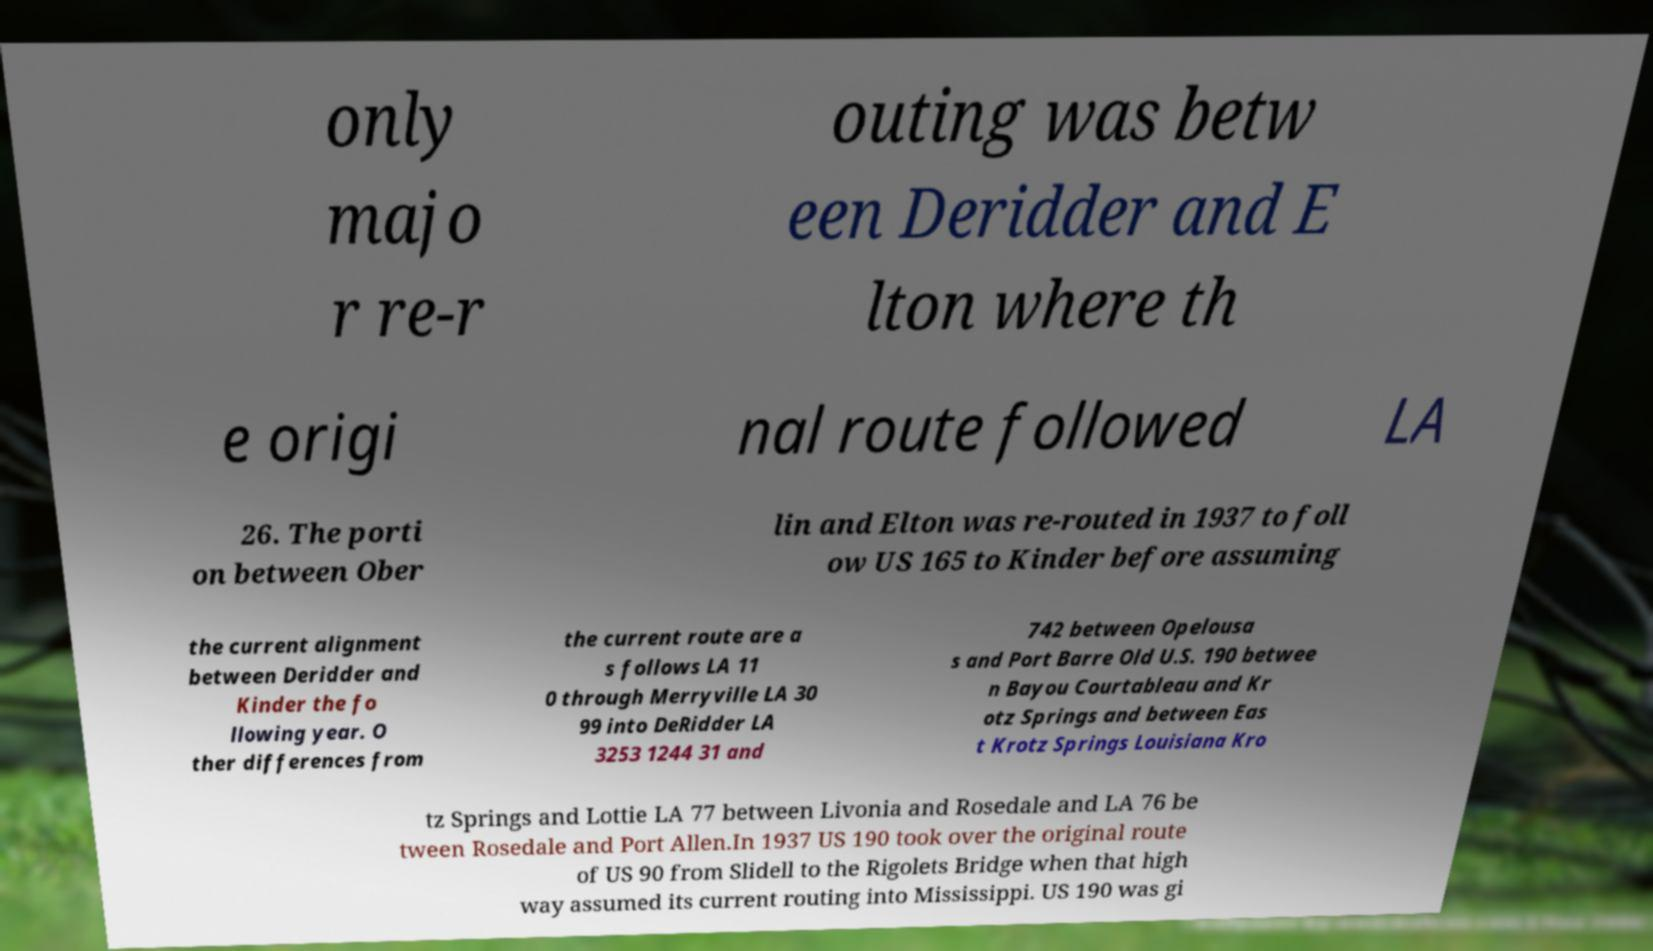Can you accurately transcribe the text from the provided image for me? only majo r re-r outing was betw een Deridder and E lton where th e origi nal route followed LA 26. The porti on between Ober lin and Elton was re-routed in 1937 to foll ow US 165 to Kinder before assuming the current alignment between Deridder and Kinder the fo llowing year. O ther differences from the current route are a s follows LA 11 0 through Merryville LA 30 99 into DeRidder LA 3253 1244 31 and 742 between Opelousa s and Port Barre Old U.S. 190 betwee n Bayou Courtableau and Kr otz Springs and between Eas t Krotz Springs Louisiana Kro tz Springs and Lottie LA 77 between Livonia and Rosedale and LA 76 be tween Rosedale and Port Allen.In 1937 US 190 took over the original route of US 90 from Slidell to the Rigolets Bridge when that high way assumed its current routing into Mississippi. US 190 was gi 